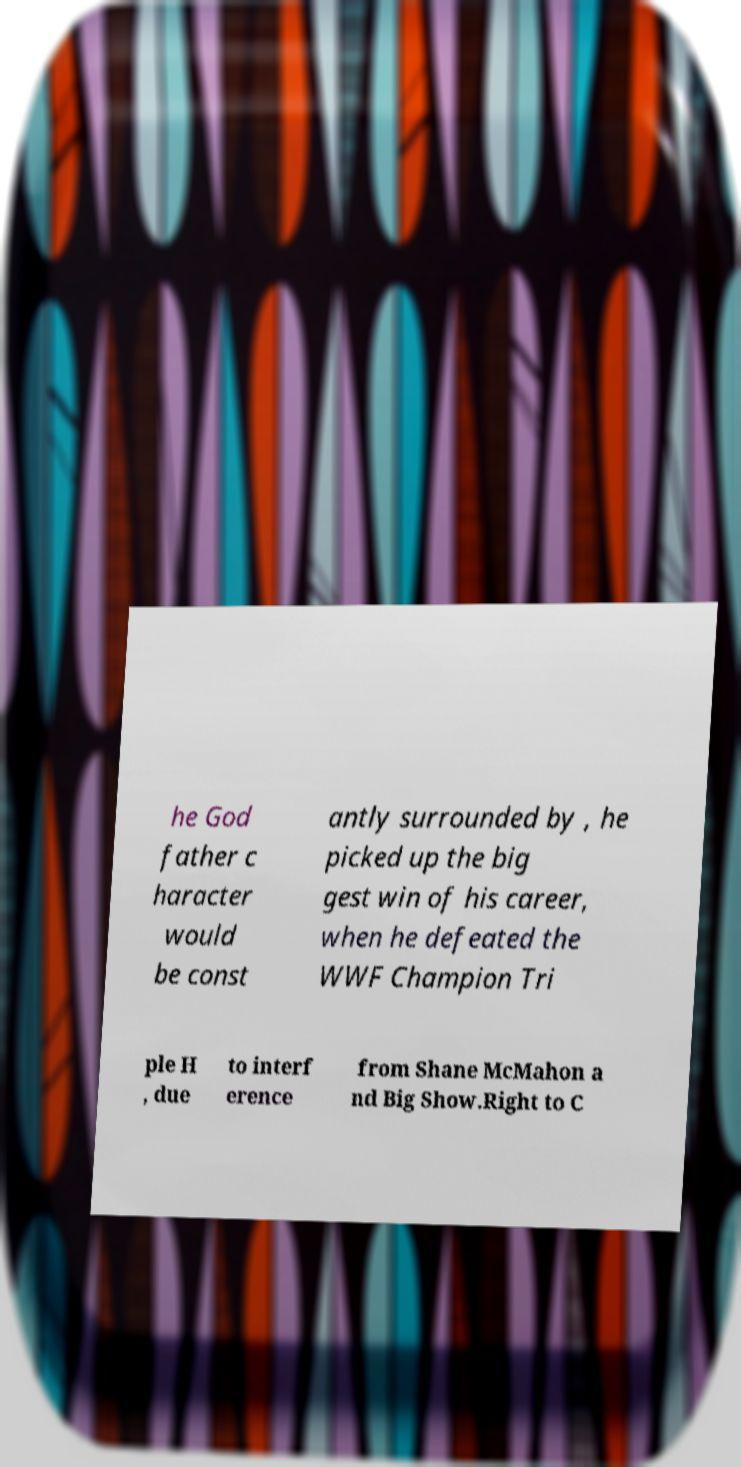Please identify and transcribe the text found in this image. he God father c haracter would be const antly surrounded by , he picked up the big gest win of his career, when he defeated the WWF Champion Tri ple H , due to interf erence from Shane McMahon a nd Big Show.Right to C 